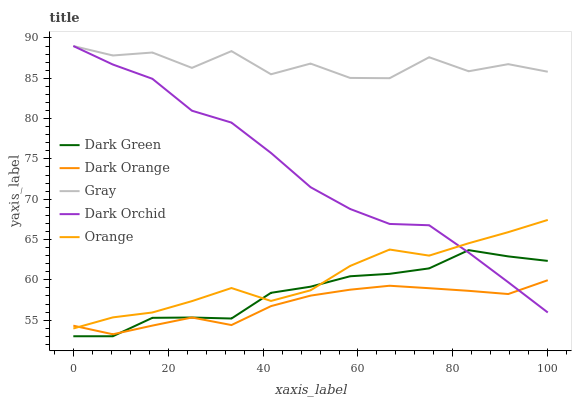Does Gray have the minimum area under the curve?
Answer yes or no. No. Does Dark Orange have the maximum area under the curve?
Answer yes or no. No. Is Gray the smoothest?
Answer yes or no. No. Is Dark Orange the roughest?
Answer yes or no. No. Does Dark Orange have the lowest value?
Answer yes or no. No. Does Dark Orange have the highest value?
Answer yes or no. No. Is Dark Orange less than Gray?
Answer yes or no. Yes. Is Gray greater than Orange?
Answer yes or no. Yes. Does Dark Orange intersect Gray?
Answer yes or no. No. 